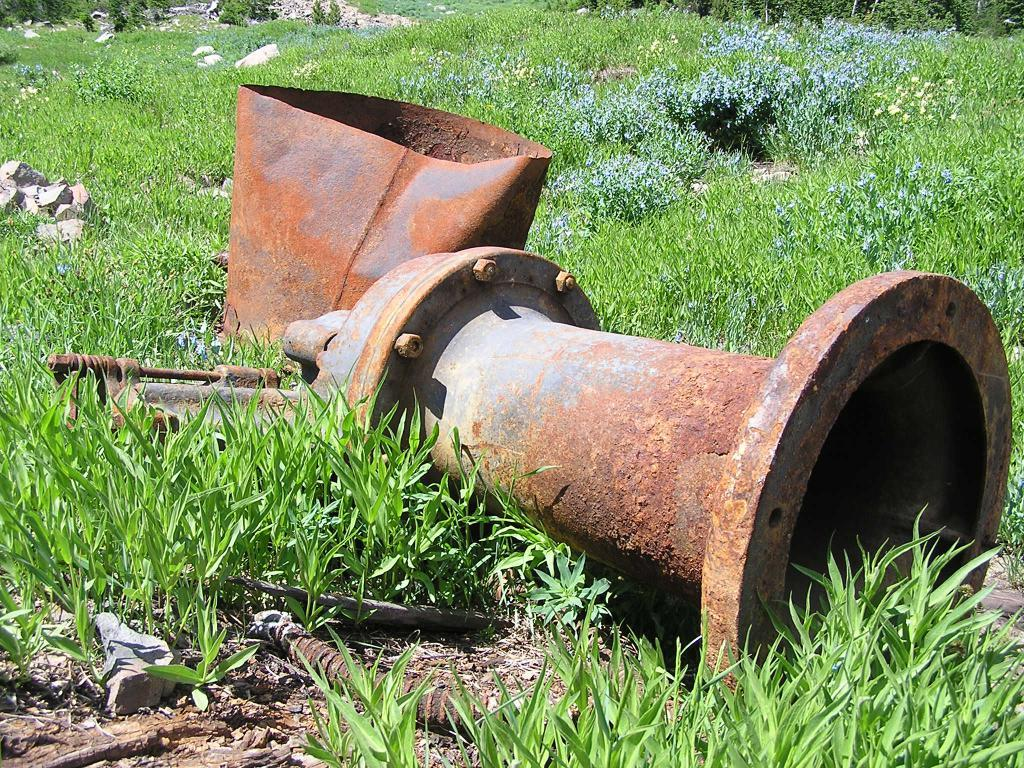What type of vegetation is at the bottom of the image? There is grass at the bottom of the image. What type of material is present in the middle of the image? There are stones in the middle of the image. Can you describe the unspecified object or feature in the middle of the image? Unfortunately, the facts provided do not specify the nature of the unspecified object or feature in the middle of the image. What type of ink is used in the company's logo in the image? There is no company or logo present in the image; it features grass and stones. What is the name of the downtown area depicted in the image? There is no downtown area depicted in the image; it features grass and stones. 